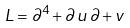<formula> <loc_0><loc_0><loc_500><loc_500>L = \partial ^ { 4 } + \partial \, u \, \partial + v</formula> 